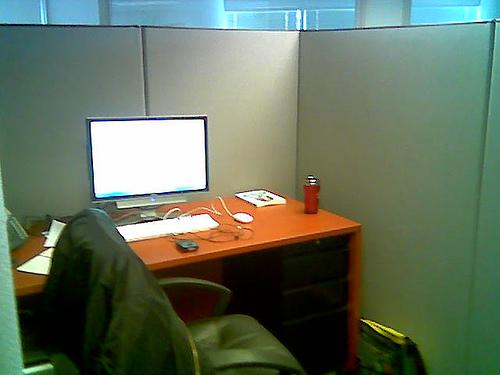What color is the computer mouse?
Write a very short answer. White. What color is the thermos?
Concise answer only. Red. Is the computer screen on?
Be succinct. Yes. 